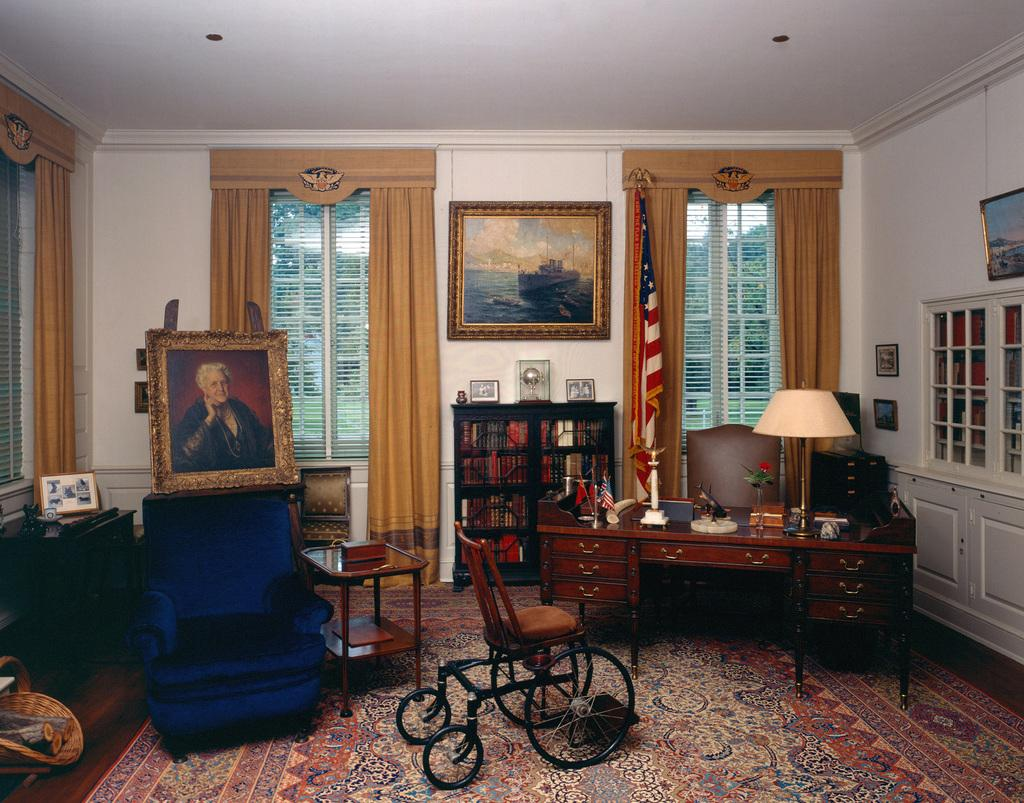What type of room is shown in the image? The image depicts a living room. What type of furniture can be seen in the living room? There are chairs in the living room. What type of decorative items are present in the living room? There are frames and flags in the living room. What type of furniture is used for placing objects in the living room? There are tables in the living room. What type of lighting is present in the living room? There are table lamps in the living room. What type of fog can be seen in the living room? There is no fog present in the living room; it is an indoor space. What type of cow is depicted in the living room? There is no cow present in the living room; the image only shows furniture, decorative items, and lighting. 